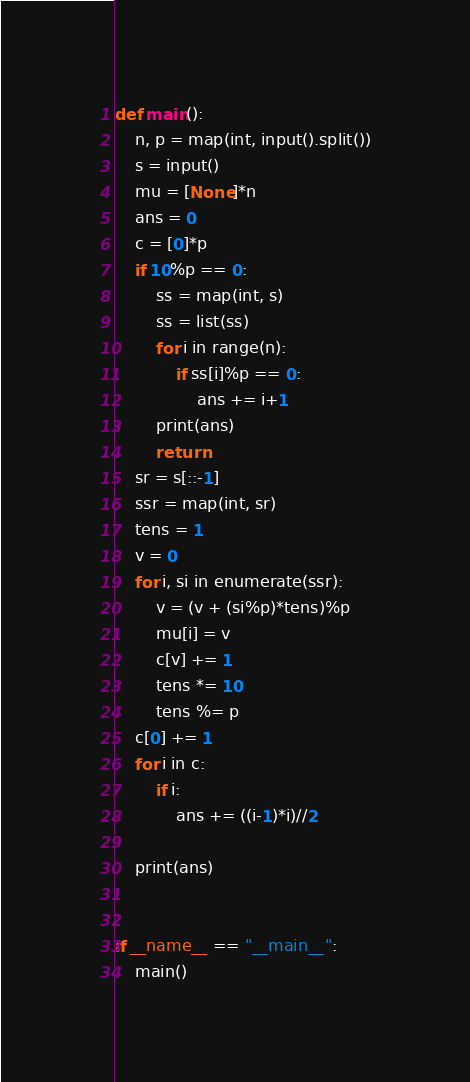<code> <loc_0><loc_0><loc_500><loc_500><_Python_>def main():
    n, p = map(int, input().split())
    s = input()
    mu = [None]*n
    ans = 0
    c = [0]*p
    if 10%p == 0:
        ss = map(int, s)
        ss = list(ss)
        for i in range(n):
            if ss[i]%p == 0:
                ans += i+1
        print(ans)
        return
    sr = s[::-1]
    ssr = map(int, sr)
    tens = 1
    v = 0
    for i, si in enumerate(ssr):
        v = (v + (si%p)*tens)%p
        mu[i] = v
        c[v] += 1
        tens *= 10
        tens %= p
    c[0] += 1
    for i in c:
        if i:
            ans += ((i-1)*i)//2
        
    print(ans)
    

if __name__ == "__main__":
    main()</code> 